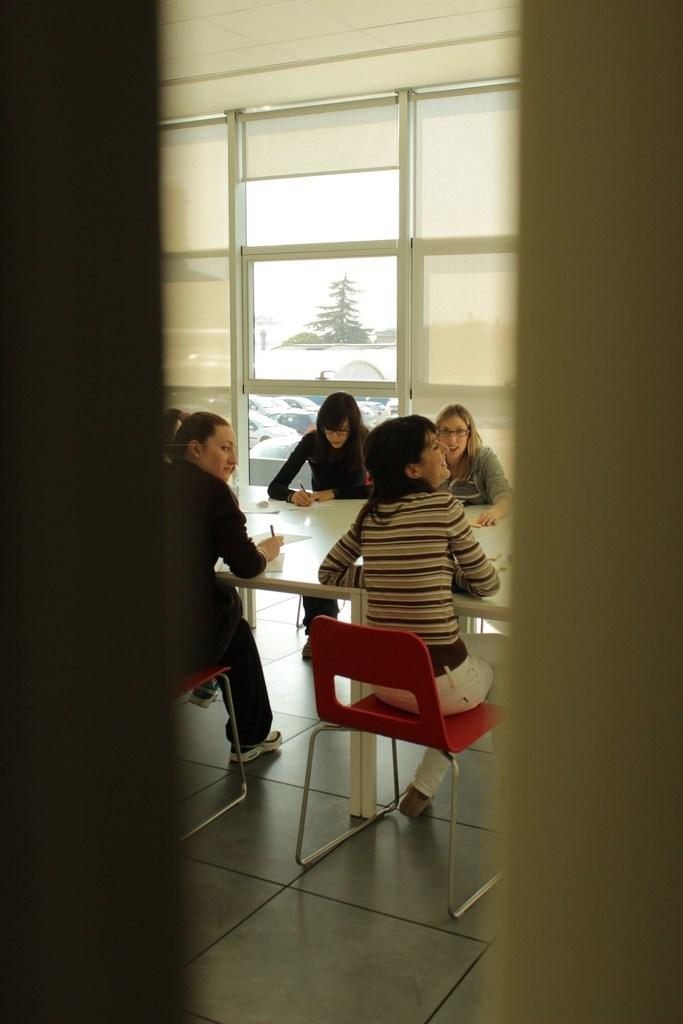What are the people in the image doing? The people in the image are sitting on chairs around a table. What objects can be seen on the table? There is a pen and a paper on the table. Is there any source of natural light in the image? Yes, there is a window in the image. What month is it in the image? The month cannot be determined from the image, as there is no information about the date or time of year. What type of ice can be seen melting on the table? There is no ice present in the image. 